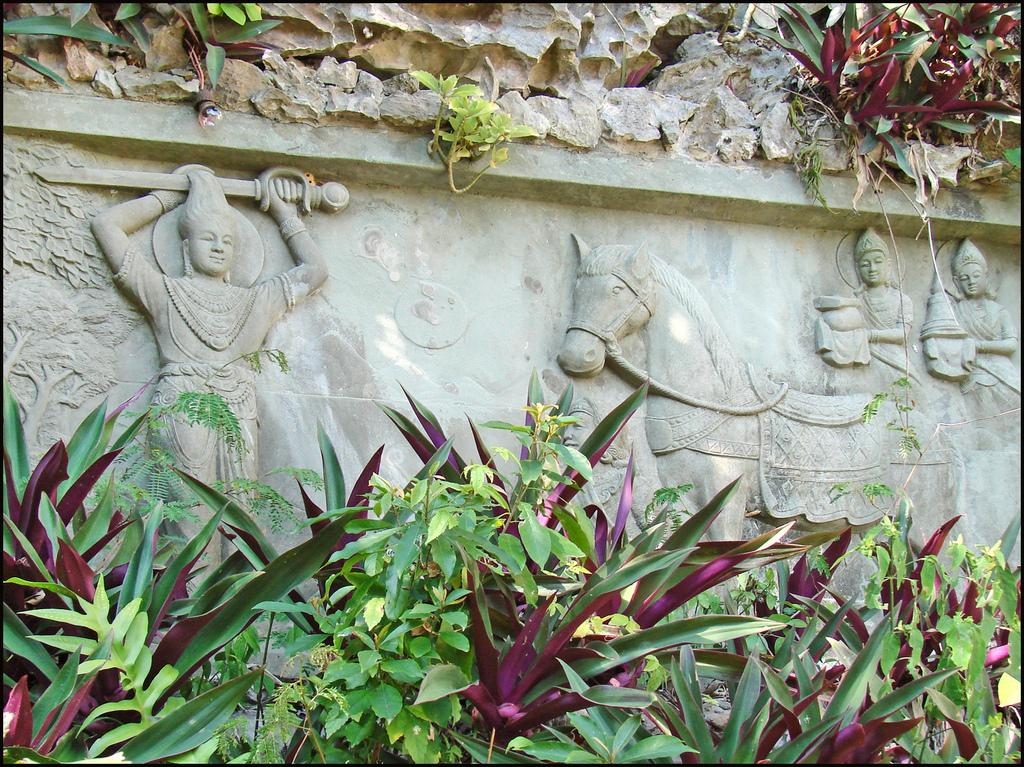What type of vegetation is present at the bottom of the image? There are plants at the bottom of the image. What can be seen on the stone in the image? There are carvings on a stone in the image. What type of material is visible at the top of the image? There are stones visible at the top of the image. What else is present at the top of the image besides stones? There are plants and a bulb present at the top of the image. What type of hospital is depicted in the image? There is no hospital present in the image; it features plants, carvings on a stone, and stones at the top and bottom. What is the mind's role in the image? The image does not depict a mind or any mental processes; it focuses on plants, carvings, and stones. 